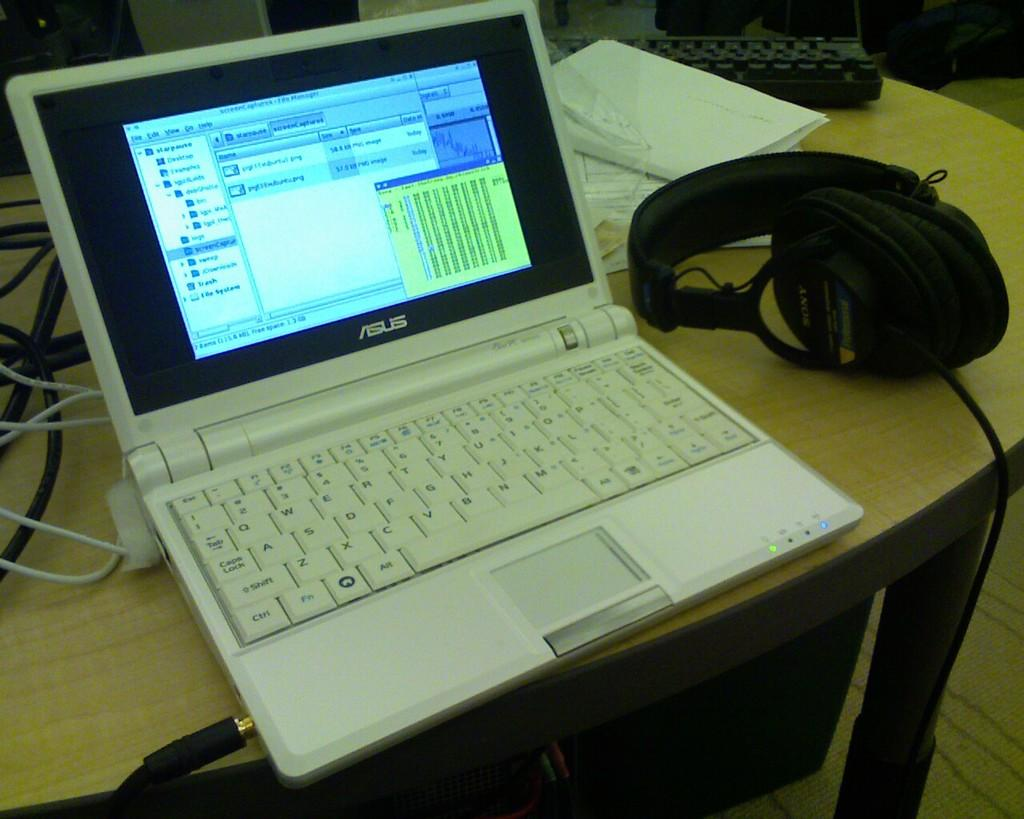What piece of furniture is present in the image? There is a table in the image. What electronic device is on the table? There is a keyboard and a laptop on the table. What accessory is also present on the table? There are headphones on the table. Where is the shelf located in the image? There is no shelf present in the image. Can you see a bee buzzing around the keyboard in the image? There is no bee present in the image. 